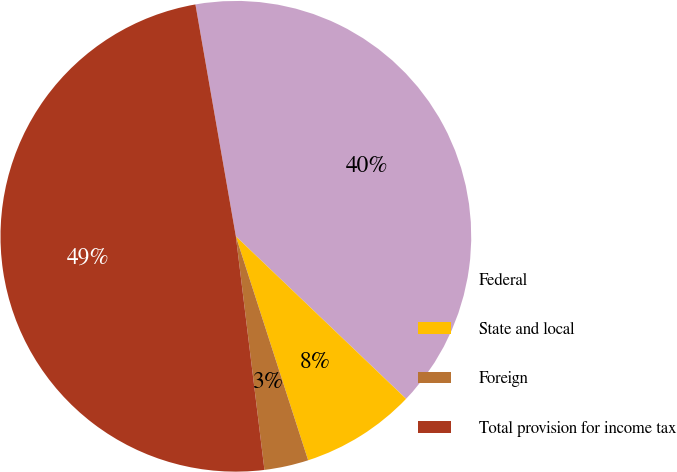Convert chart to OTSL. <chart><loc_0><loc_0><loc_500><loc_500><pie_chart><fcel>Federal<fcel>State and local<fcel>Foreign<fcel>Total provision for income tax<nl><fcel>39.88%<fcel>7.9%<fcel>3.03%<fcel>49.19%<nl></chart> 